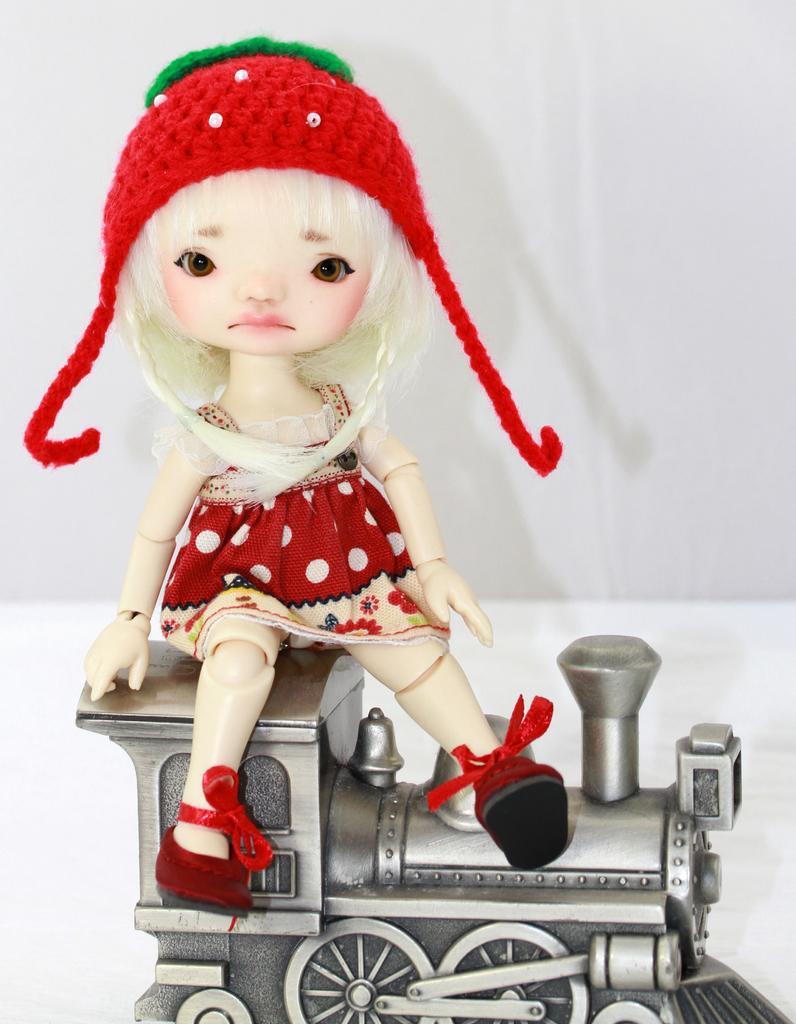Please provide a concise description of this image. In this picture we can see a toy on the surface. 